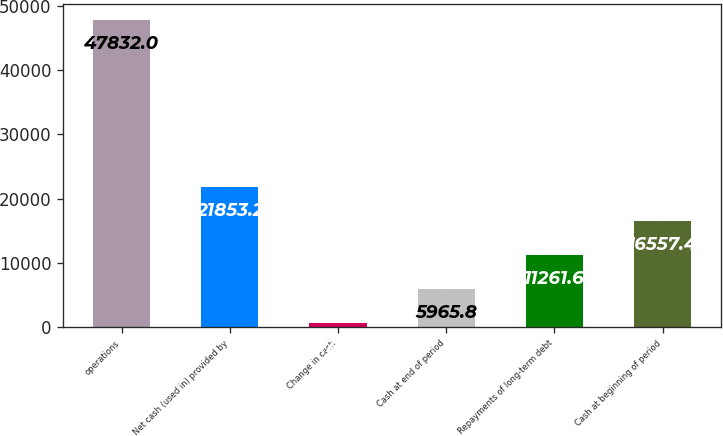Convert chart. <chart><loc_0><loc_0><loc_500><loc_500><bar_chart><fcel>operations<fcel>Net cash (used in) provided by<fcel>Change in cash<fcel>Cash at end of period<fcel>Repayments of long-term debt<fcel>Cash at beginning of period<nl><fcel>47832<fcel>21853.2<fcel>670<fcel>5965.8<fcel>11261.6<fcel>16557.4<nl></chart> 